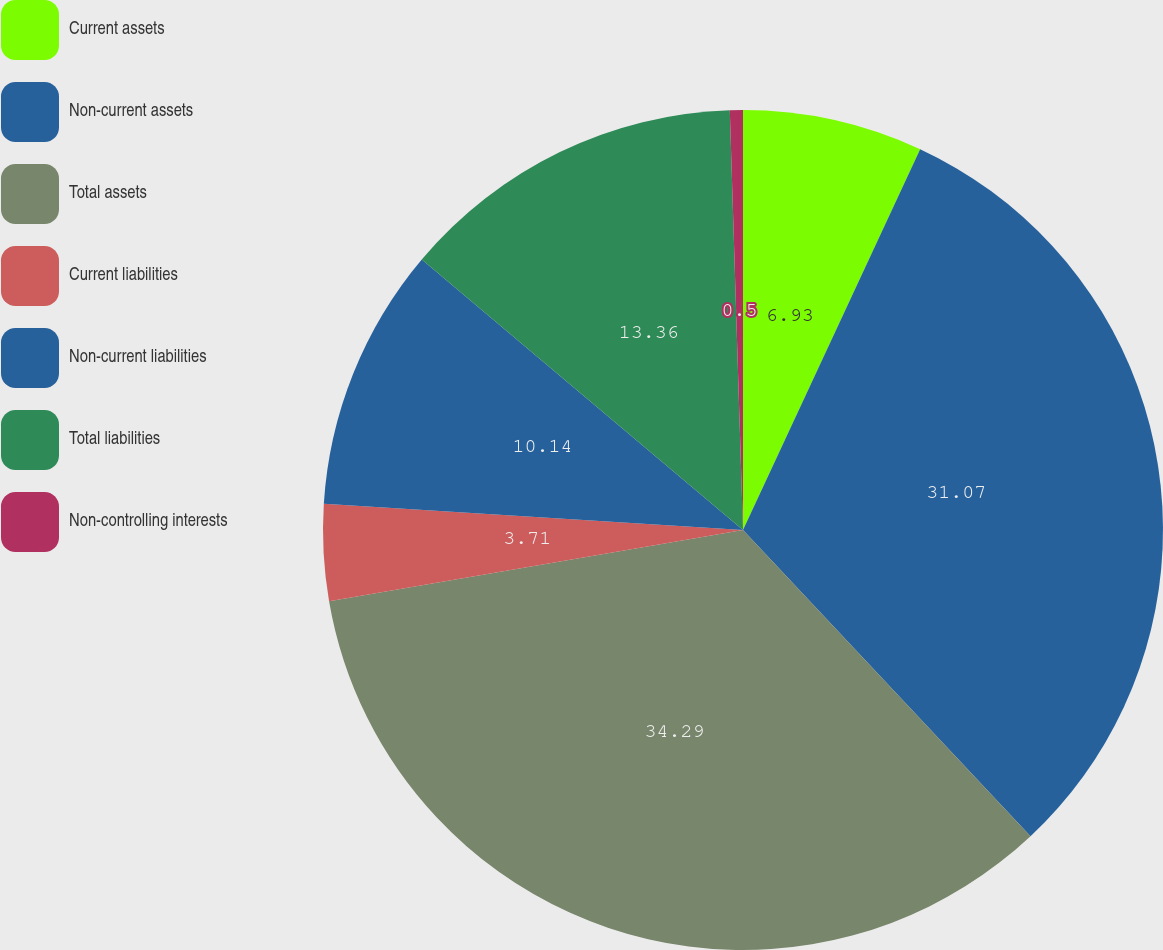Convert chart. <chart><loc_0><loc_0><loc_500><loc_500><pie_chart><fcel>Current assets<fcel>Non-current assets<fcel>Total assets<fcel>Current liabilities<fcel>Non-current liabilities<fcel>Total liabilities<fcel>Non-controlling interests<nl><fcel>6.93%<fcel>31.07%<fcel>34.29%<fcel>3.71%<fcel>10.14%<fcel>13.36%<fcel>0.5%<nl></chart> 